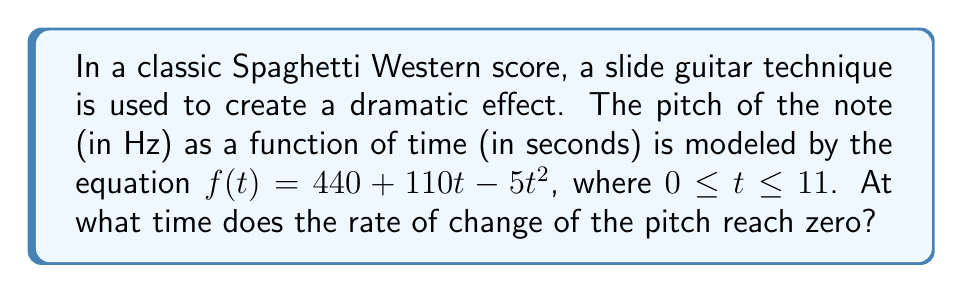Give your solution to this math problem. To solve this problem, we need to follow these steps:

1) The rate of change of the pitch is given by the derivative of $f(t)$. Let's call this $f'(t)$.

2) To find $f'(t)$, we differentiate $f(t)$ with respect to $t$:

   $f'(t) = \frac{d}{dt}(440 + 110t - 5t^2)$
   $f'(t) = 0 + 110 - 10t$
   $f'(t) = 110 - 10t$

3) We want to find when this rate of change is zero, so we set $f'(t) = 0$:

   $110 - 10t = 0$

4) Solve this equation for $t$:

   $-10t = -110$
   $t = 11$

5) We need to check if this value of $t$ is within the given domain $0 \leq t \leq 11$. It is, so this solution is valid.

Therefore, the rate of change of the pitch reaches zero at $t = 11$ seconds.
Answer: 11 seconds 